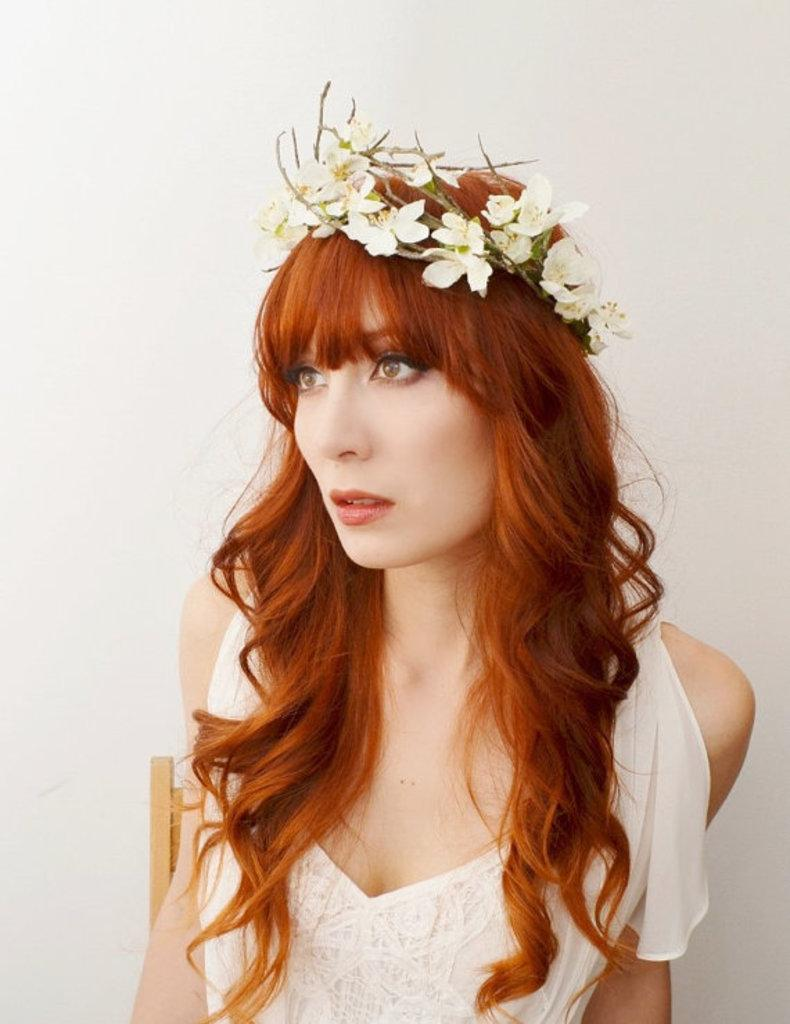Who is the main subject in the image? There is a woman in the image. What is the woman wearing? The woman is wearing a white dress. Can you describe the woman's hair? The woman has brown hair. What is on the woman's head? There are flowers on the woman's head. What can be seen in the background of the image? There is a wall in the background of the image. What color is the wall? The wall is white in color. What type of crate is visible in the image? There is no crate present in the image. Can you tell me how many gold coins are on the woman's dress? There are no gold coins on the woman's dress in the image. 